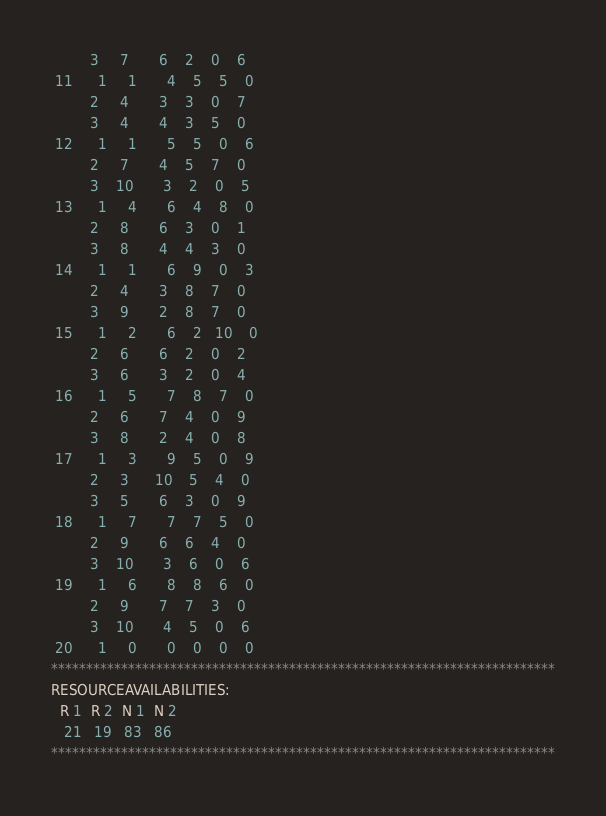Convert code to text. <code><loc_0><loc_0><loc_500><loc_500><_ObjectiveC_>         3     7       6    2    0    6
 11      1     1       4    5    5    0
         2     4       3    3    0    7
         3     4       4    3    5    0
 12      1     1       5    5    0    6
         2     7       4    5    7    0
         3    10       3    2    0    5
 13      1     4       6    4    8    0
         2     8       6    3    0    1
         3     8       4    4    3    0
 14      1     1       6    9    0    3
         2     4       3    8    7    0
         3     9       2    8    7    0
 15      1     2       6    2   10    0
         2     6       6    2    0    2
         3     6       3    2    0    4
 16      1     5       7    8    7    0
         2     6       7    4    0    9
         3     8       2    4    0    8
 17      1     3       9    5    0    9
         2     3      10    5    4    0
         3     5       6    3    0    9
 18      1     7       7    7    5    0
         2     9       6    6    4    0
         3    10       3    6    0    6
 19      1     6       8    8    6    0
         2     9       7    7    3    0
         3    10       4    5    0    6
 20      1     0       0    0    0    0
************************************************************************
RESOURCEAVAILABILITIES:
  R 1  R 2  N 1  N 2
   21   19   83   86
************************************************************************
</code> 